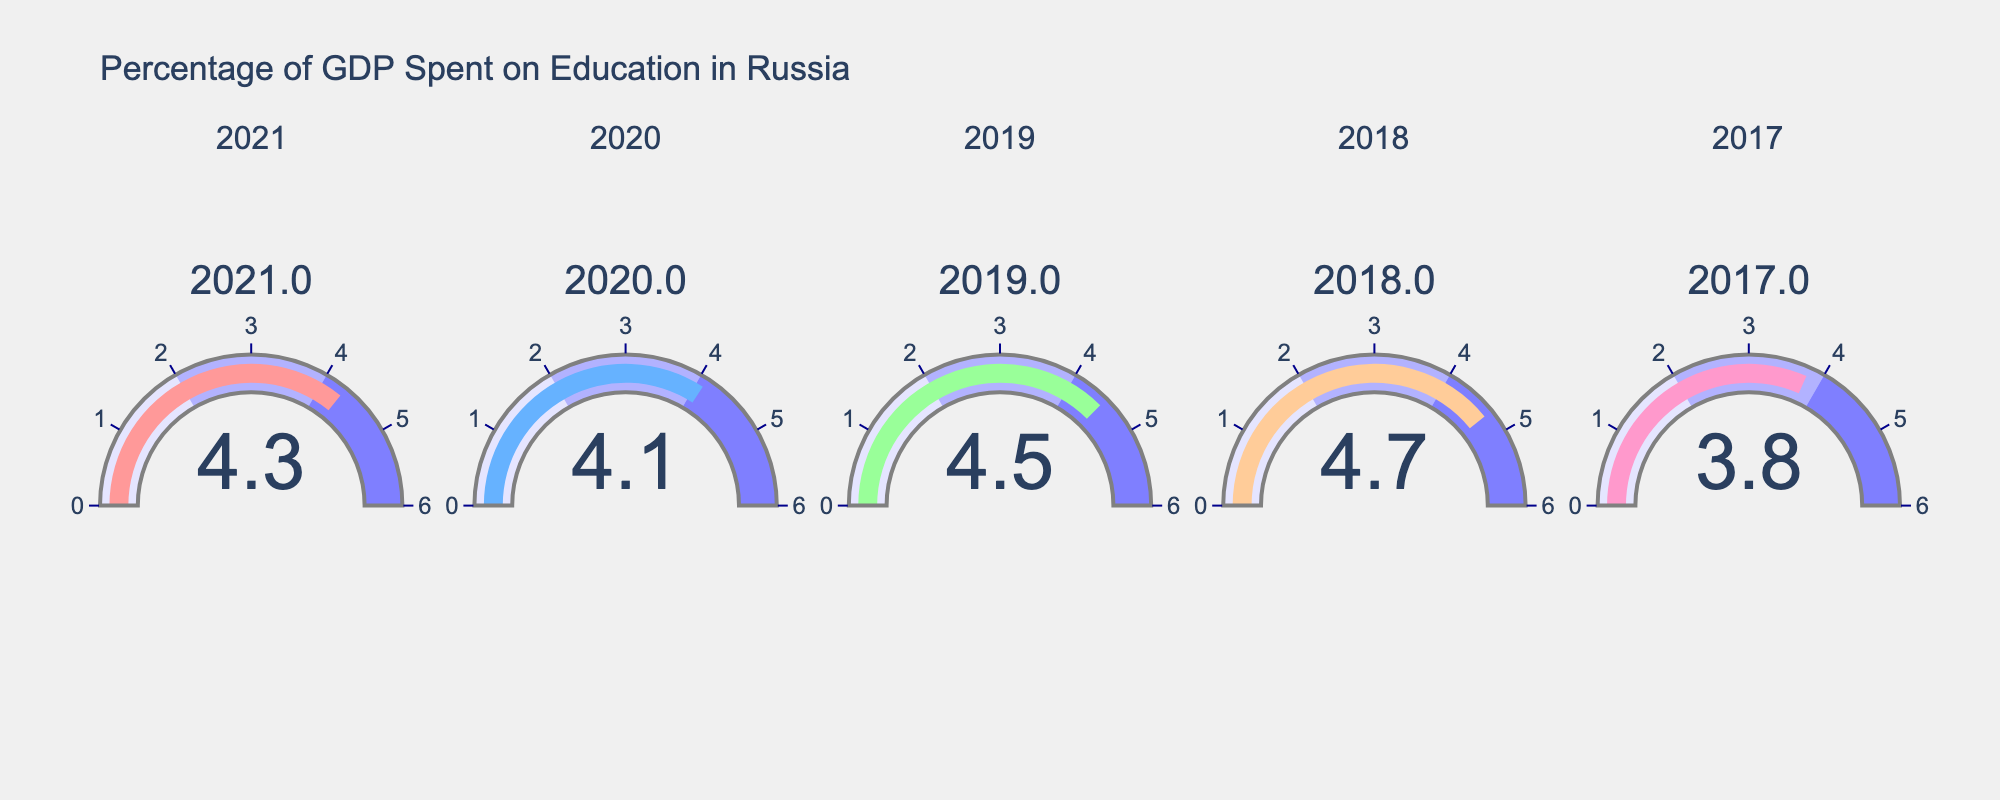What is the title of the figure? The title is usually displayed at the top of the figure and indicates the overall subject of the visualization. The title here reads "Percentage of GDP Spent on Education in Russia".
Answer: Percentage of GDP Spent on Education in Russia How many years of data are displayed in the figure? Each gauge represents a single year, and there are 5 gauges in total, each indicating one year.
Answer: 5 What is the highest percentage of GDP spent on education, and in which year did it occur? By looking at the values shown in each gauge, the highest percentage is 4.7, which occurred in 2018.
Answer: 4.7 in 2018 Compare the percentage of GDP spent on education in 2020 and 2021. Which year had a higher percentage and by how much? The gauge for 2021 shows 4.3% and for 2020 shows 4.1%. To find the difference, subtract 4.1 from 4.3.
Answer: 2021 by 0.2% Calculate the average percentage of GDP spent on education from 2017 to 2021. The values for the years 2017 to 2021 are 3.8, 4.7, 4.5, 4.1, and 4.3. To find the average, sum these values and divide by the number of years. (3.8 + 4.7 + 4.5 + 4.1 + 4.3) / 5 = 21.4 / 5 = 4.28.
Answer: 4.28 Which year had the lowest percentage of GDP spent on education? By examining the values on each gauge, the lowest percentage is 3.8, which occurred in 2017.
Answer: 2017 What is the median percentage of GDP spent on education from 2017 to 2021? List the percentages in ascending order: 3.8, 4.1, 4.3, 4.5, 4.7. The median is the middle value, which is 4.3.
Answer: 4.3 Compare the percentage change in GDP spent on education from 2019 to 2020. Was there an increase or a decrease, and by how much? The percentage for 2019 is 4.5 and for 2020 is 4.1. Calculate the change by subtracting 4.1 from 4.5. It decreased by 0.4%.
Answer: Decrease by 0.4% What percentage of GDP spent on education ranks second highest among the years shown? Order the percentages: 3.8, 4.1, 4.3, 4.5, 4.7. The second highest percentage is 4.5, which occurred in 2019.
Answer: 4.5 